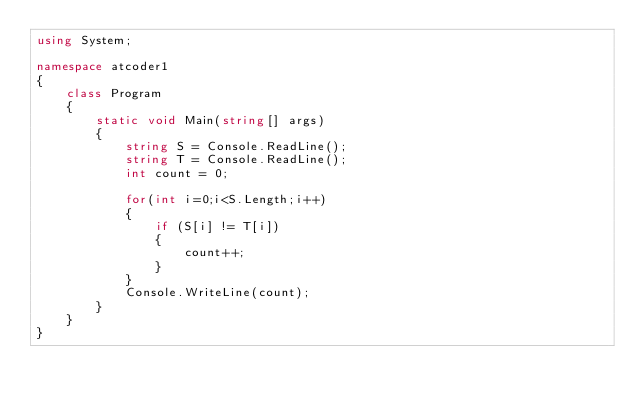<code> <loc_0><loc_0><loc_500><loc_500><_C#_>using System;

namespace atcoder1
{
    class Program
    {
        static void Main(string[] args)
        {
            string S = Console.ReadLine();
            string T = Console.ReadLine();
            int count = 0;

            for(int i=0;i<S.Length;i++)
            {
                if (S[i] != T[i])
                {
                    count++;
                }
            }
            Console.WriteLine(count);
        }
    }
}
</code> 